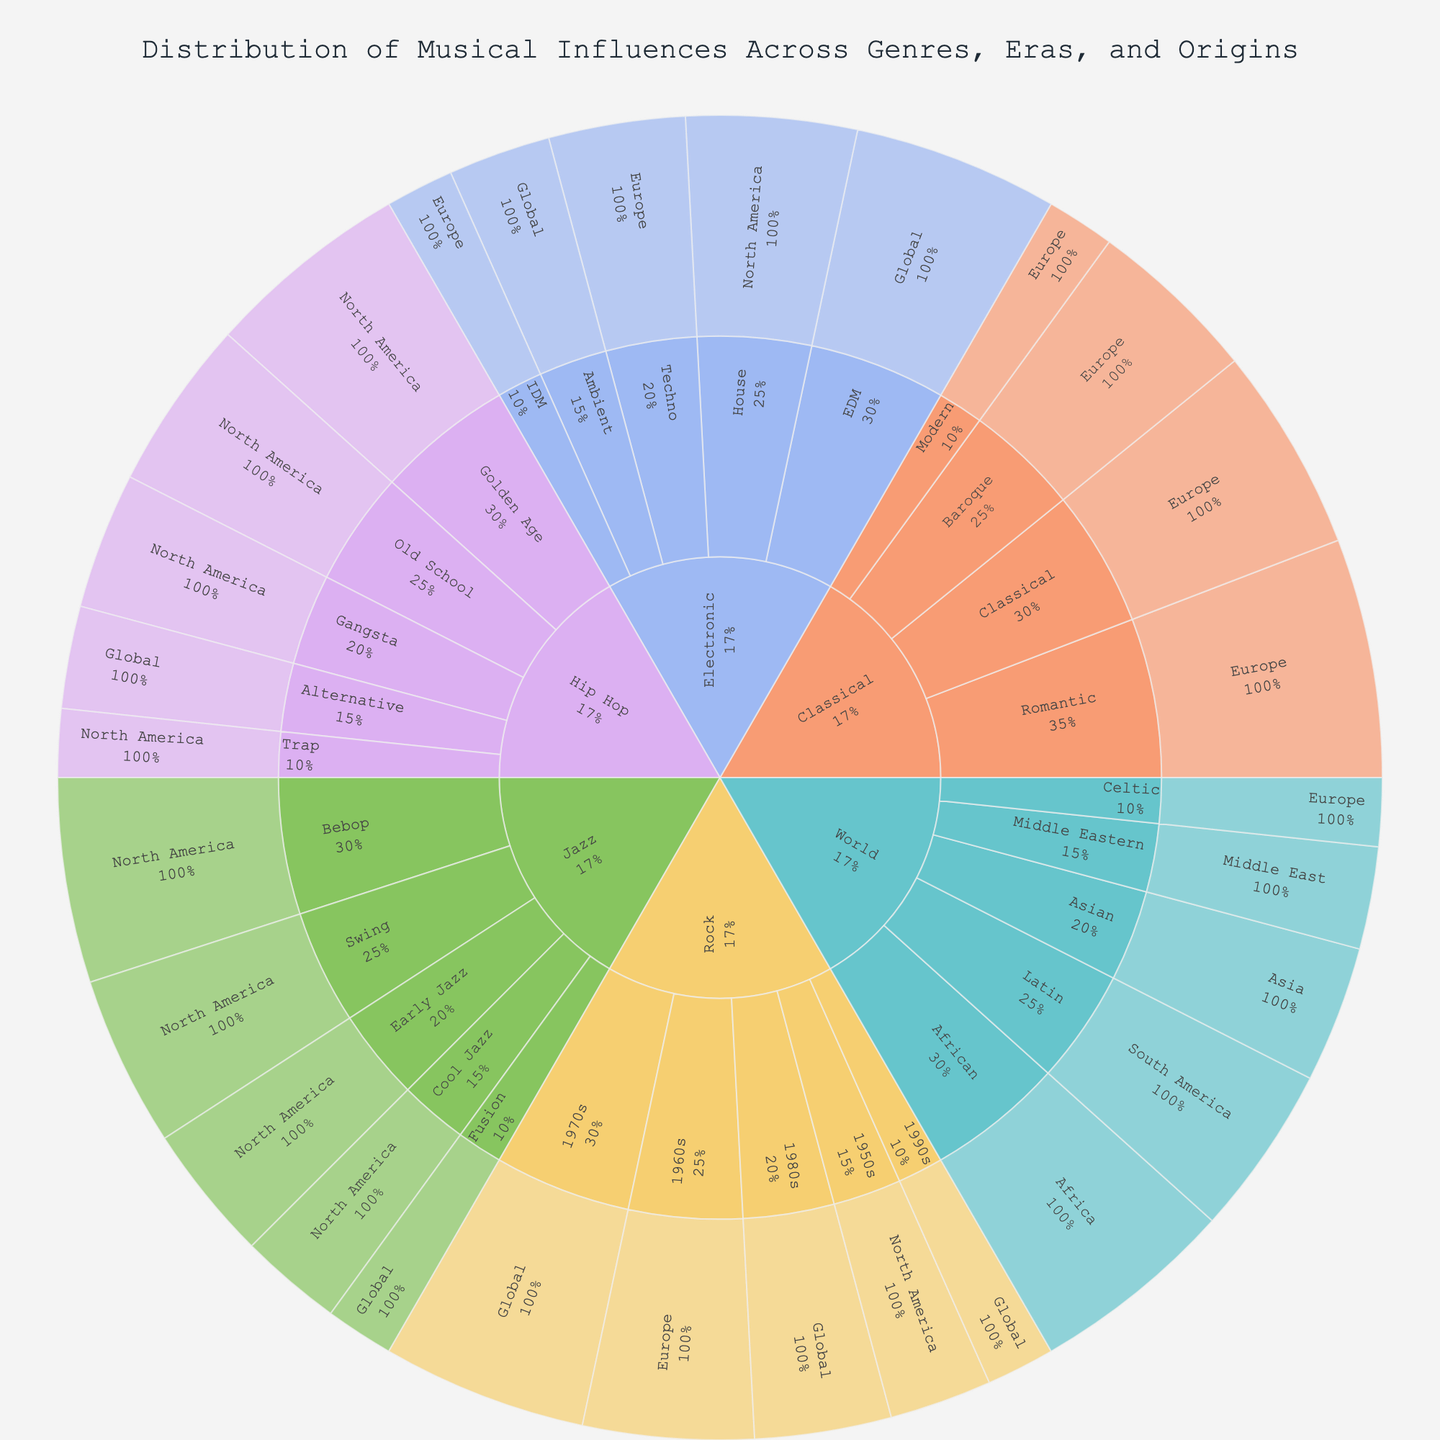Which genre has the highest total influence? Summing the influences across eras for each genre, Rock has: 15 (1950s) + 25 (1960s) + 30 (1970s) + 20 (1980s) + 10 (1990s) = 100. Among genres, Rock has the highest total influence.
Answer: Rock How does the influence of Jazz in Swing compare to Bebop? From the figure, the influence of Jazz in Swing is 25, while in Bebop, it is 30. Therefore, Bebop has a higher influence than Swing.
Answer: Bebop has higher influence What percentage of the total influence of Classical is from the Baroque era? The total influence of Classical is 25 (Baroque) + 30 (Classical) + 35 (Romantic) + 10 (Modern) = 100. The Baroque era contributes 25%.
Answer: 25% Which era has the least influence in the World genre? The World genre includes African (30), Latin (25), Asian (20), Middle Eastern (15), and Celtic (10). Celtic, from Europe, has the least influence.
Answer: Celtic How much more influential is Hip Hop’s Golden Age era compared to Trap? The influence of Hip Hop’s Golden Age is 30, while Trap is 10. The difference in influence is 30 - 10 = 20.
Answer: 20 How is the influence distributed globally among Rock eras? For Rock, the global influences are 30 (1970s), 20 (1980s), 10 (1990s). Summed up, the global influence is 30 + 20 + 10 = 60.
Answer: 60 Which region contributes the most to the influence of Electronic music? The Electronic genre has influences from Europe (Techno 20, IDM 10), North America (House 25), and Global (Ambient 15, EDM 30). Europe's total is 20 + 10 = 30, North America's is 25, and Global's is 15 + 30 = 45. Global contributes the most.
Answer: Global What is the combined influence of Classical and Electronic music? Summing the influences, Classical: 25 (Baroque) + 30 (Classical) + 35 (Romantic) + 10 (Modern) = 100; Electronic: 20 (Techno) + 25 (House) + 15 (Ambient) + 30 (EDM) + 10 (IDM) = 100; Combined influence = 100 + 100 = 200.
Answer: 200 Is the influence of Latin music in the World genre greater than the influence of Cool Jazz? The influence of Latin in the World genre is 25, while Cool Jazz in Jazz is 15. Therefore, Latin has a greater influence than Cool Jazz.
Answer: Yes What is the influence of Classical music from the Romantic era relative to the total influence of all eras in the Jazz genre? The influence of Classical music from the Romantic era is 35. The total influence of Jazz is 20 (Early Jazz) + 25 (Swing) + 30 (Bebop) + 15 (Cool Jazz) + 10 (Fusion) = 100. The relative influence is 35/100 = 35%.
Answer: 35% 